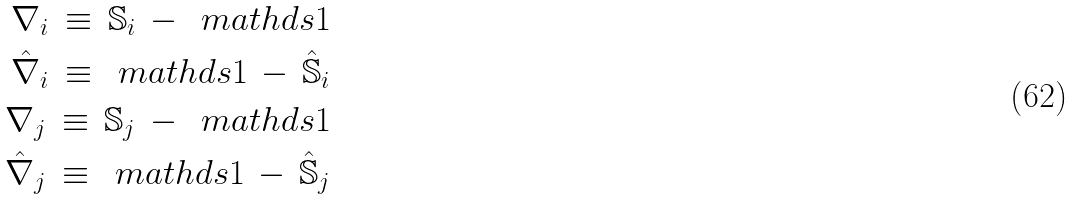Convert formula to latex. <formula><loc_0><loc_0><loc_500><loc_500>\nabla _ { i } \, \equiv \, \mathbb { S } _ { i } \, - \, \ m a t h d s { 1 } \\ \hat { \nabla } _ { i } \, \equiv \, \ m a t h d s { 1 } \, - \, \hat { \mathbb { S } } _ { i } \\ \nabla _ { j } \, \equiv \, \mathbb { S } _ { j } \, - \, \ m a t h d s { 1 } \\ \hat { \nabla } _ { j } \, \equiv \, \ m a t h d s { 1 } \, - \, \hat { \mathbb { S } } _ { j }</formula> 